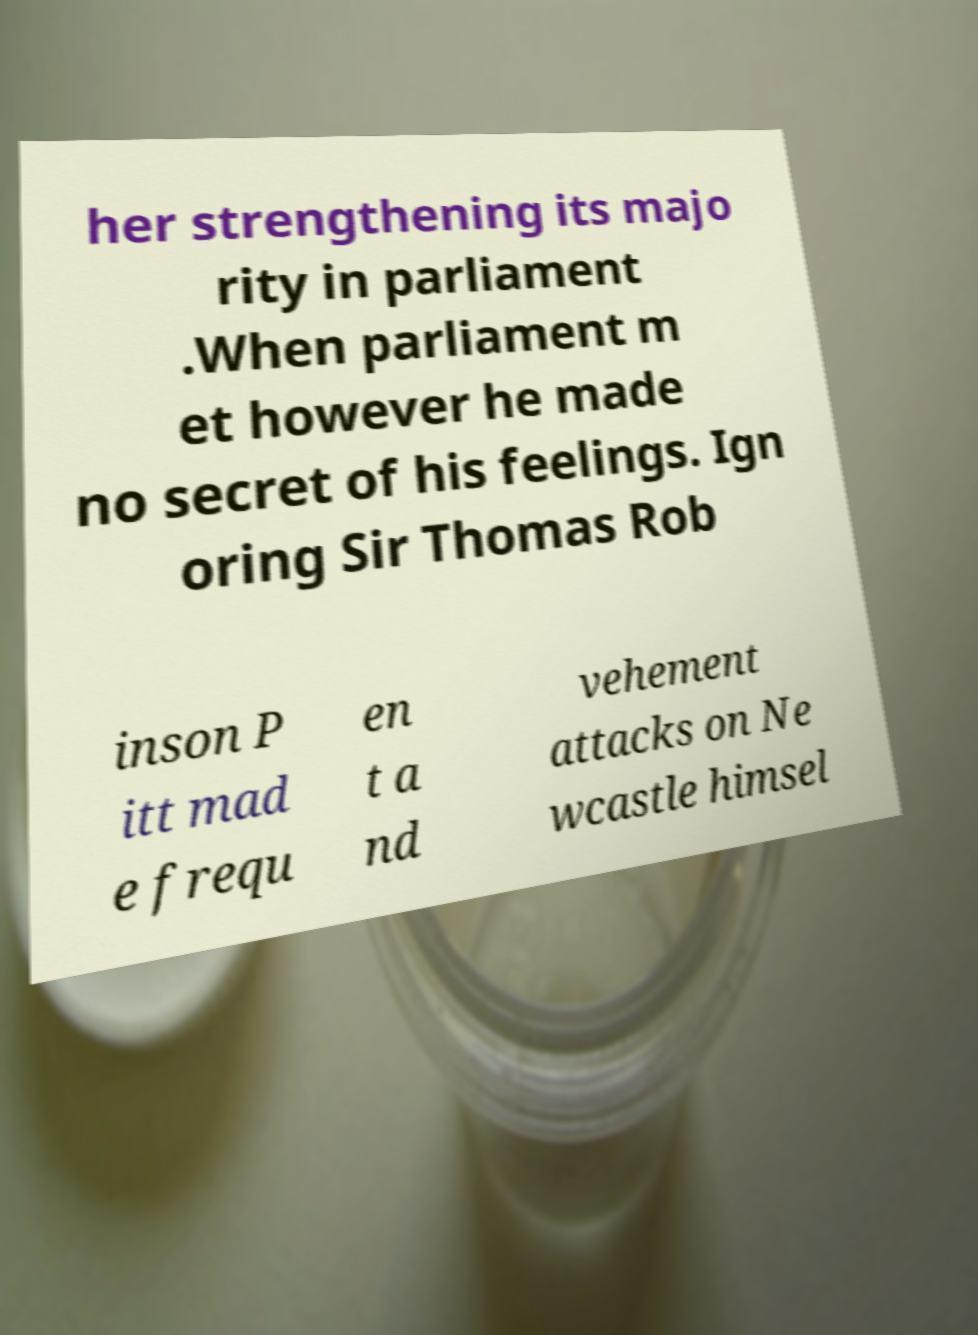Could you assist in decoding the text presented in this image and type it out clearly? her strengthening its majo rity in parliament .When parliament m et however he made no secret of his feelings. Ign oring Sir Thomas Rob inson P itt mad e frequ en t a nd vehement attacks on Ne wcastle himsel 